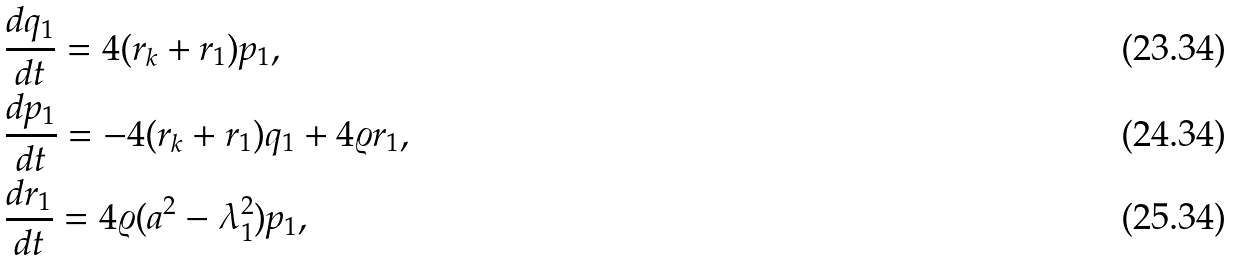<formula> <loc_0><loc_0><loc_500><loc_500>& \frac { d q _ { 1 } } { d t } = 4 ( r _ { k } + r _ { 1 } ) p _ { 1 } , \\ & \frac { d p _ { 1 } } { d t } = - 4 ( r _ { k } + r _ { 1 } ) q _ { 1 } + 4 \varrho r _ { 1 } , \\ & \frac { d r _ { 1 } } { d t } = 4 \varrho ( a ^ { 2 } - \lambda _ { 1 } ^ { 2 } ) p _ { 1 } ,</formula> 